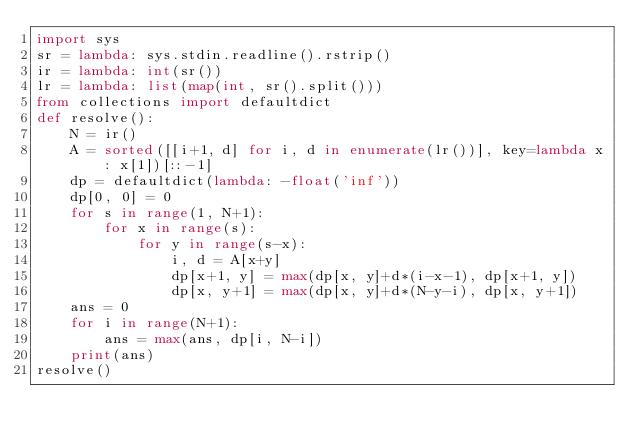<code> <loc_0><loc_0><loc_500><loc_500><_Python_>import sys
sr = lambda: sys.stdin.readline().rstrip()
ir = lambda: int(sr())
lr = lambda: list(map(int, sr().split()))
from collections import defaultdict
def resolve():
    N = ir()
    A = sorted([[i+1, d] for i, d in enumerate(lr())], key=lambda x: x[1])[::-1]
    dp = defaultdict(lambda: -float('inf'))
    dp[0, 0] = 0
    for s in range(1, N+1):
        for x in range(s):
            for y in range(s-x):
                i, d = A[x+y]
                dp[x+1, y] = max(dp[x, y]+d*(i-x-1), dp[x+1, y])
                dp[x, y+1] = max(dp[x, y]+d*(N-y-i), dp[x, y+1])
    ans = 0
    for i in range(N+1):
        ans = max(ans, dp[i, N-i])
    print(ans)
resolve()</code> 